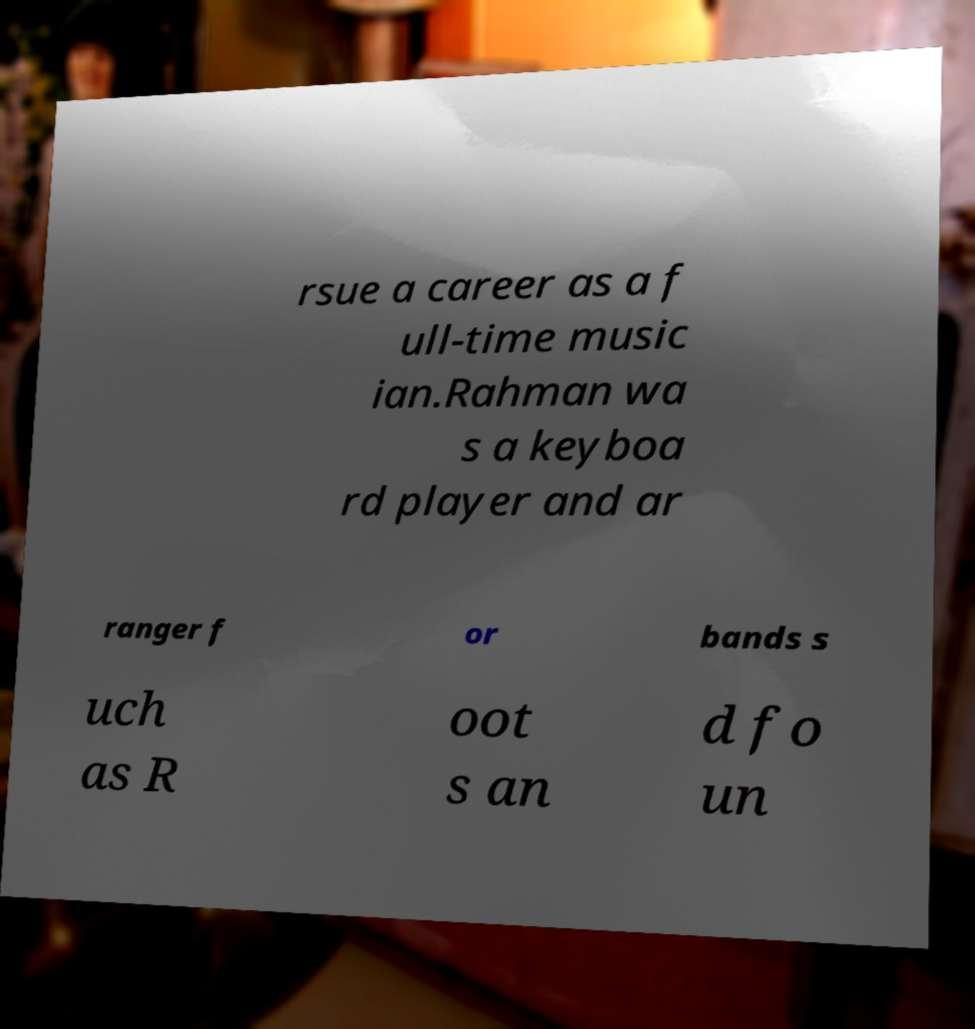Can you accurately transcribe the text from the provided image for me? rsue a career as a f ull-time music ian.Rahman wa s a keyboa rd player and ar ranger f or bands s uch as R oot s an d fo un 